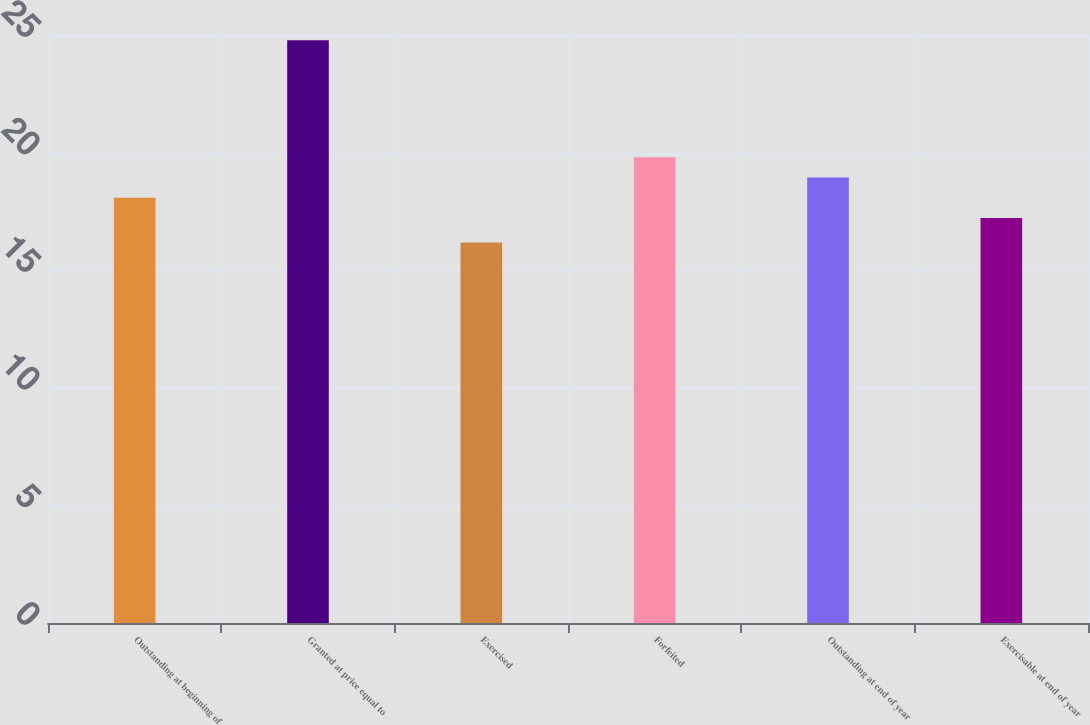Convert chart. <chart><loc_0><loc_0><loc_500><loc_500><bar_chart><fcel>Outstanding at beginning of<fcel>Granted at price equal to<fcel>Exercised<fcel>Forfeited<fcel>Outstanding at end of year<fcel>Exercisable at end of year<nl><fcel>18.08<fcel>24.78<fcel>16.18<fcel>19.8<fcel>18.94<fcel>17.22<nl></chart> 